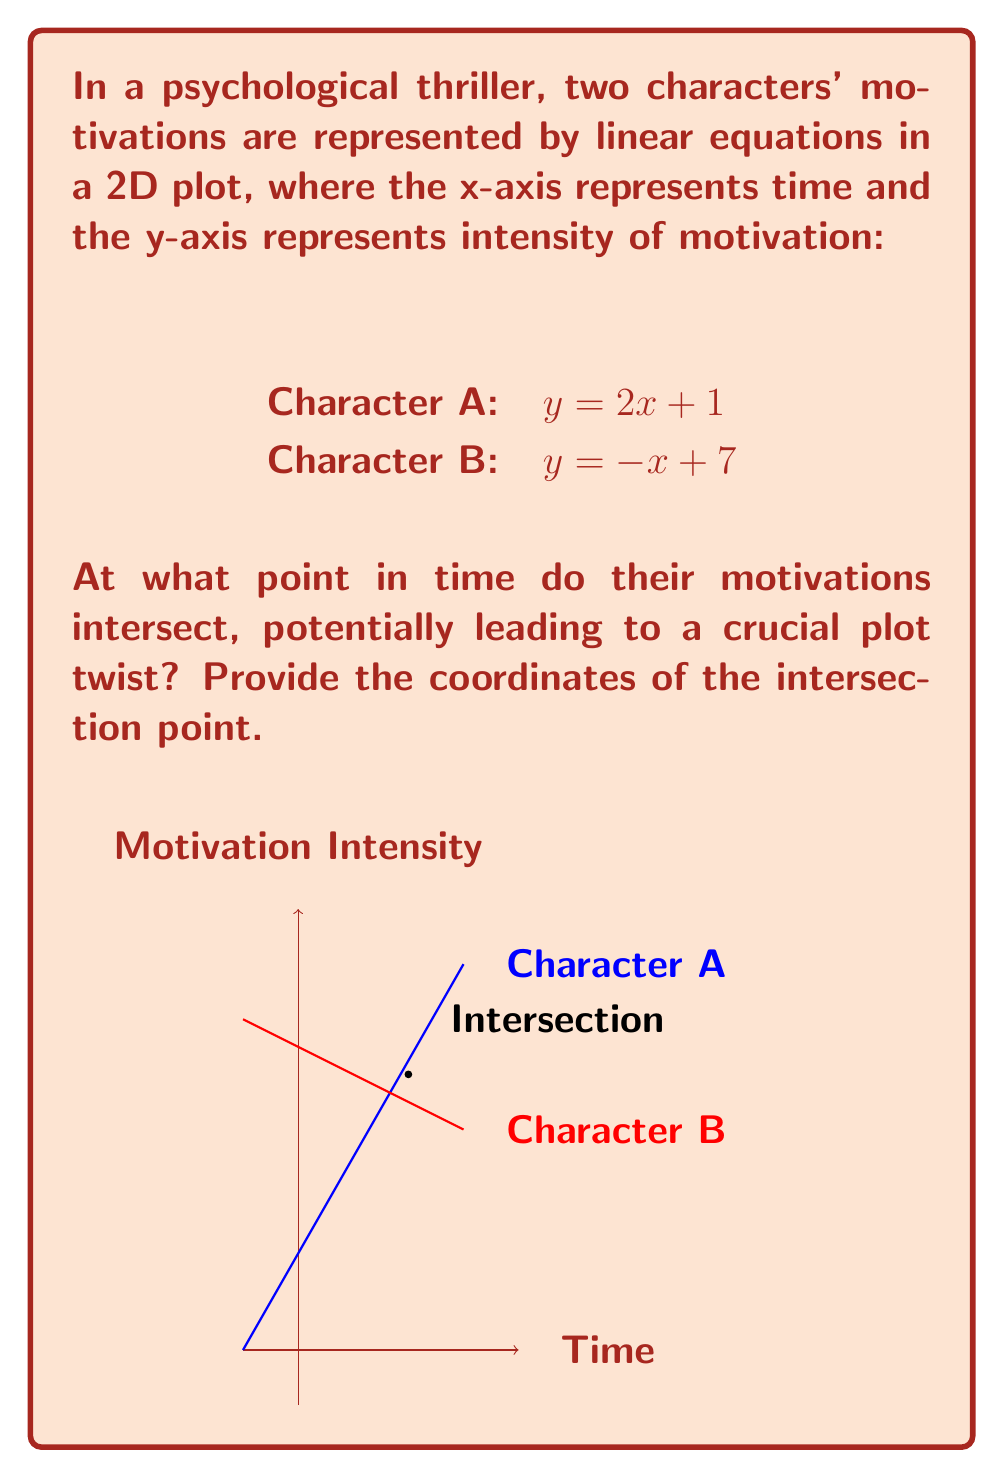Could you help me with this problem? To find the intersection point of these two lines, we need to solve the system of equations:

$$\begin{cases}
y = 2x + 1 \\
y = -x + 7
\end{cases}$$

Step 1: Since both equations are equal to y, we can set them equal to each other:
$2x + 1 = -x + 7$

Step 2: Add x to both sides:
$3x + 1 = 7$

Step 3: Subtract 1 from both sides:
$3x = 6$

Step 4: Divide both sides by 3:
$x = 2$

Step 5: Now that we know x, we can substitute it into either of the original equations to find y. Let's use Character A's equation:

$y = 2x + 1$
$y = 2(2) + 1$
$y = 4 + 1 = 5$

Therefore, the intersection point is (2, 5).

Interpretation: The characters' motivations intersect at time t = 2 with an intensity of 5. This could represent a crucial moment in the story where their conflicting motivations come to a head, potentially leading to a significant plot development or twist.
Answer: (2, 5) 